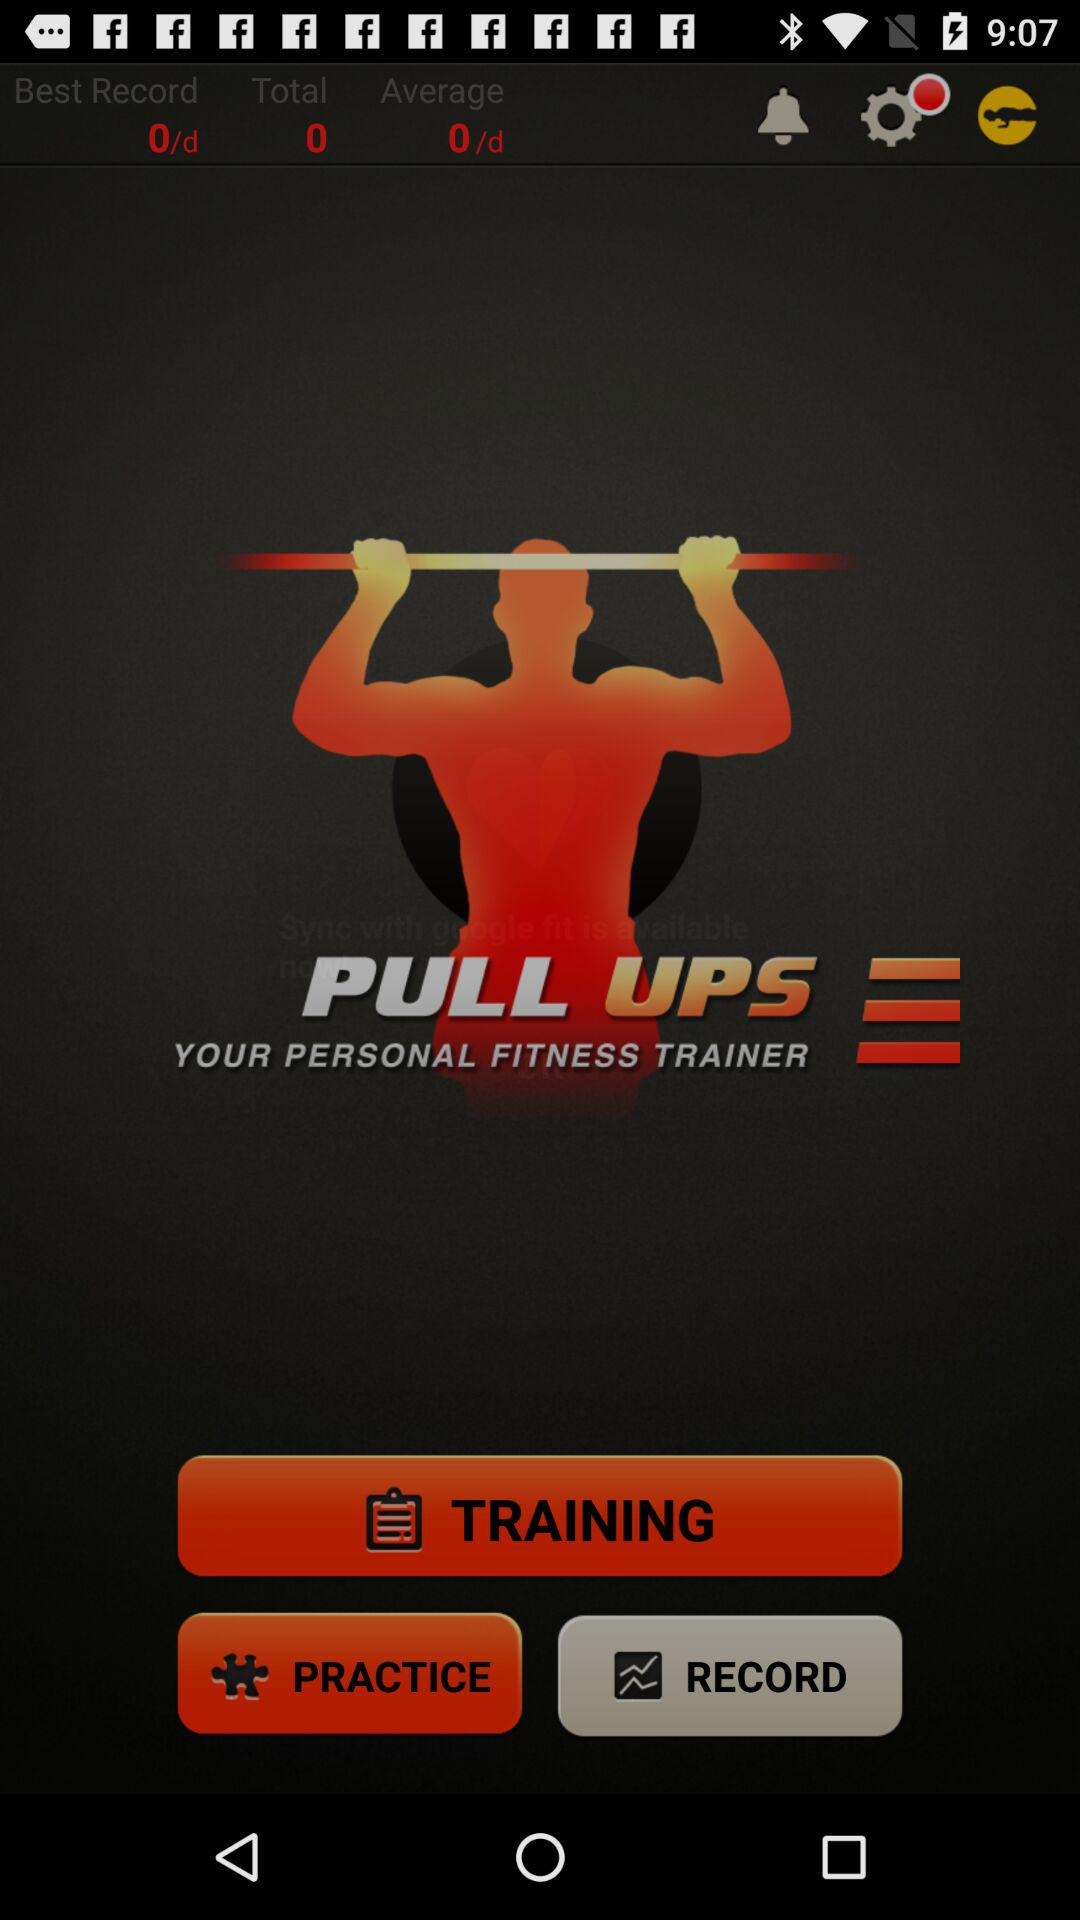What is the best record? The best record is 0/d. 